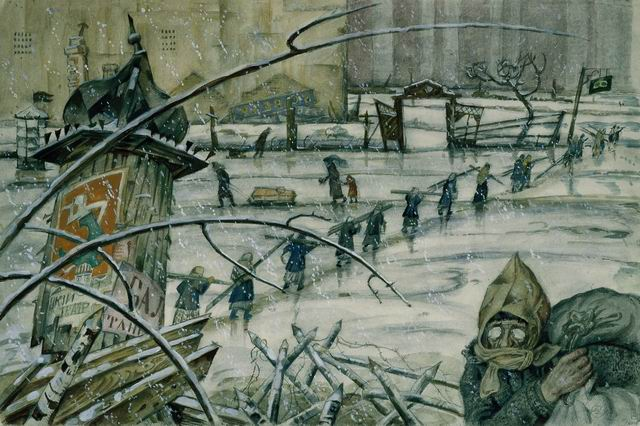If you were to write a story about this scene, what would be its central theme? The central theme of the story would revolve around survival in the face of adversity. It would explore the experiences of the individuals captured in the scene, delving into their struggles, the impact of the conflict on their lives, and their resilience as they navigate through the grim realities of their environment. The story would highlight themes of human endurance, the toll of war on civilians, and the hope for a brighter future amidst the bleakness. 